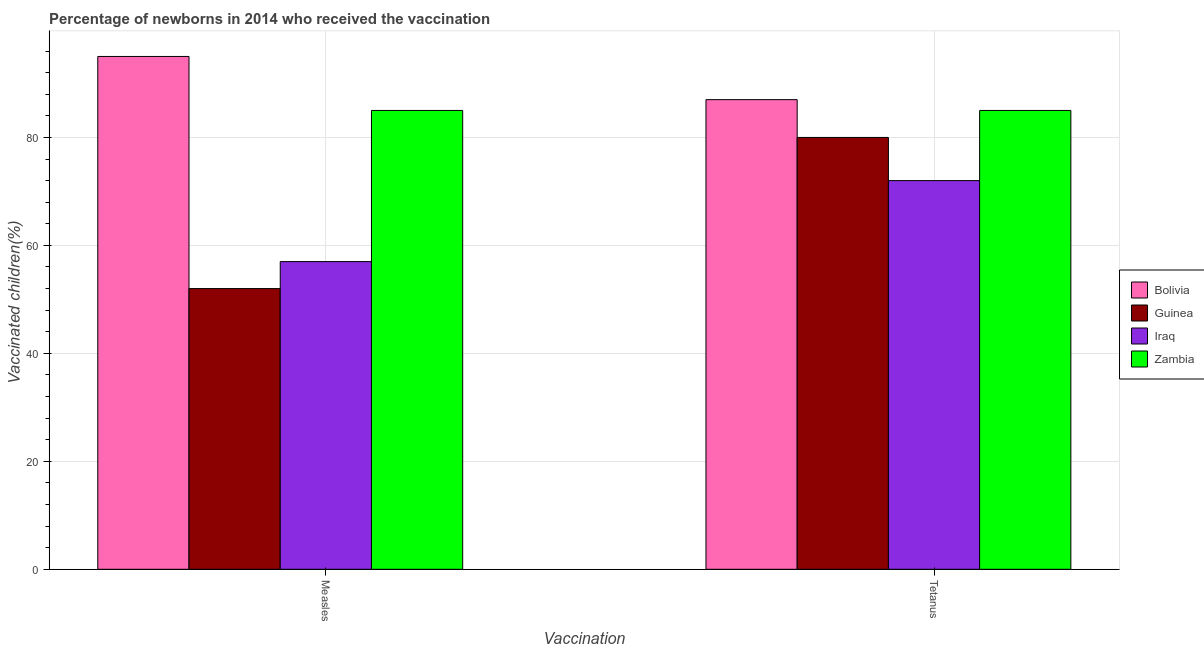Are the number of bars on each tick of the X-axis equal?
Give a very brief answer. Yes. How many bars are there on the 2nd tick from the left?
Make the answer very short. 4. What is the label of the 1st group of bars from the left?
Your response must be concise. Measles. What is the percentage of newborns who received vaccination for tetanus in Zambia?
Give a very brief answer. 85. Across all countries, what is the maximum percentage of newborns who received vaccination for measles?
Give a very brief answer. 95. Across all countries, what is the minimum percentage of newborns who received vaccination for measles?
Offer a terse response. 52. In which country was the percentage of newborns who received vaccination for tetanus maximum?
Your answer should be very brief. Bolivia. In which country was the percentage of newborns who received vaccination for measles minimum?
Your answer should be compact. Guinea. What is the total percentage of newborns who received vaccination for measles in the graph?
Give a very brief answer. 289. What is the difference between the percentage of newborns who received vaccination for measles in Bolivia and that in Iraq?
Offer a terse response. 38. What is the difference between the percentage of newborns who received vaccination for tetanus in Bolivia and the percentage of newborns who received vaccination for measles in Iraq?
Offer a terse response. 30. What is the average percentage of newborns who received vaccination for measles per country?
Offer a terse response. 72.25. What is the difference between the percentage of newborns who received vaccination for tetanus and percentage of newborns who received vaccination for measles in Iraq?
Offer a terse response. 15. What is the ratio of the percentage of newborns who received vaccination for measles in Zambia to that in Iraq?
Give a very brief answer. 1.49. Is the percentage of newborns who received vaccination for measles in Iraq less than that in Bolivia?
Keep it short and to the point. Yes. In how many countries, is the percentage of newborns who received vaccination for tetanus greater than the average percentage of newborns who received vaccination for tetanus taken over all countries?
Offer a terse response. 2. What does the 4th bar from the left in Tetanus represents?
Offer a very short reply. Zambia. What does the 3rd bar from the right in Tetanus represents?
Offer a terse response. Guinea. Are all the bars in the graph horizontal?
Ensure brevity in your answer.  No. What is the difference between two consecutive major ticks on the Y-axis?
Your response must be concise. 20. Are the values on the major ticks of Y-axis written in scientific E-notation?
Give a very brief answer. No. Does the graph contain any zero values?
Provide a succinct answer. No. How many legend labels are there?
Provide a succinct answer. 4. How are the legend labels stacked?
Give a very brief answer. Vertical. What is the title of the graph?
Make the answer very short. Percentage of newborns in 2014 who received the vaccination. What is the label or title of the X-axis?
Give a very brief answer. Vaccination. What is the label or title of the Y-axis?
Ensure brevity in your answer.  Vaccinated children(%)
. What is the Vaccinated children(%)
 in Bolivia in Measles?
Make the answer very short. 95. What is the Vaccinated children(%)
 of Guinea in Measles?
Ensure brevity in your answer.  52. What is the Vaccinated children(%)
 of Iraq in Measles?
Your response must be concise. 57. What is the Vaccinated children(%)
 in Zambia in Measles?
Make the answer very short. 85. What is the Vaccinated children(%)
 in Guinea in Tetanus?
Give a very brief answer. 80. What is the Vaccinated children(%)
 in Zambia in Tetanus?
Your answer should be very brief. 85. Across all Vaccination, what is the maximum Vaccinated children(%)
 of Guinea?
Your answer should be compact. 80. Across all Vaccination, what is the maximum Vaccinated children(%)
 of Iraq?
Offer a terse response. 72. Across all Vaccination, what is the maximum Vaccinated children(%)
 in Zambia?
Your answer should be very brief. 85. Across all Vaccination, what is the minimum Vaccinated children(%)
 in Iraq?
Your response must be concise. 57. What is the total Vaccinated children(%)
 of Bolivia in the graph?
Ensure brevity in your answer.  182. What is the total Vaccinated children(%)
 of Guinea in the graph?
Provide a short and direct response. 132. What is the total Vaccinated children(%)
 in Iraq in the graph?
Ensure brevity in your answer.  129. What is the total Vaccinated children(%)
 of Zambia in the graph?
Provide a short and direct response. 170. What is the difference between the Vaccinated children(%)
 of Bolivia in Measles and that in Tetanus?
Give a very brief answer. 8. What is the difference between the Vaccinated children(%)
 in Iraq in Measles and that in Tetanus?
Your answer should be compact. -15. What is the difference between the Vaccinated children(%)
 in Guinea in Measles and the Vaccinated children(%)
 in Zambia in Tetanus?
Offer a very short reply. -33. What is the difference between the Vaccinated children(%)
 in Iraq in Measles and the Vaccinated children(%)
 in Zambia in Tetanus?
Your response must be concise. -28. What is the average Vaccinated children(%)
 in Bolivia per Vaccination?
Offer a terse response. 91. What is the average Vaccinated children(%)
 of Guinea per Vaccination?
Make the answer very short. 66. What is the average Vaccinated children(%)
 in Iraq per Vaccination?
Your answer should be very brief. 64.5. What is the average Vaccinated children(%)
 of Zambia per Vaccination?
Give a very brief answer. 85. What is the difference between the Vaccinated children(%)
 in Bolivia and Vaccinated children(%)
 in Guinea in Measles?
Keep it short and to the point. 43. What is the difference between the Vaccinated children(%)
 in Bolivia and Vaccinated children(%)
 in Zambia in Measles?
Offer a very short reply. 10. What is the difference between the Vaccinated children(%)
 in Guinea and Vaccinated children(%)
 in Iraq in Measles?
Provide a short and direct response. -5. What is the difference between the Vaccinated children(%)
 of Guinea and Vaccinated children(%)
 of Zambia in Measles?
Your response must be concise. -33. What is the difference between the Vaccinated children(%)
 in Bolivia and Vaccinated children(%)
 in Zambia in Tetanus?
Offer a terse response. 2. What is the difference between the Vaccinated children(%)
 of Guinea and Vaccinated children(%)
 of Zambia in Tetanus?
Offer a very short reply. -5. What is the ratio of the Vaccinated children(%)
 in Bolivia in Measles to that in Tetanus?
Your answer should be compact. 1.09. What is the ratio of the Vaccinated children(%)
 of Guinea in Measles to that in Tetanus?
Your answer should be very brief. 0.65. What is the ratio of the Vaccinated children(%)
 of Iraq in Measles to that in Tetanus?
Make the answer very short. 0.79. What is the ratio of the Vaccinated children(%)
 of Zambia in Measles to that in Tetanus?
Provide a succinct answer. 1. What is the difference between the highest and the second highest Vaccinated children(%)
 of Bolivia?
Keep it short and to the point. 8. What is the difference between the highest and the second highest Vaccinated children(%)
 of Guinea?
Keep it short and to the point. 28. What is the difference between the highest and the second highest Vaccinated children(%)
 in Iraq?
Give a very brief answer. 15. What is the difference between the highest and the second highest Vaccinated children(%)
 of Zambia?
Ensure brevity in your answer.  0. What is the difference between the highest and the lowest Vaccinated children(%)
 of Bolivia?
Make the answer very short. 8. What is the difference between the highest and the lowest Vaccinated children(%)
 in Guinea?
Provide a succinct answer. 28. What is the difference between the highest and the lowest Vaccinated children(%)
 of Zambia?
Offer a very short reply. 0. 